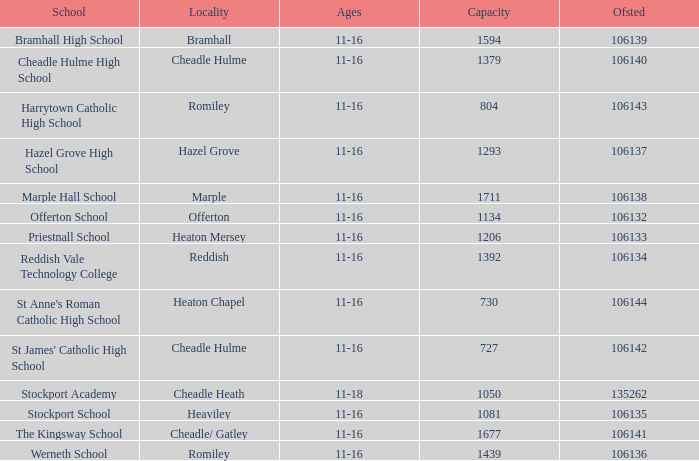Which educational institution has an age range of 11-16, an ofsted number less than 106142, and a capacity of 1206? Priestnall School. 